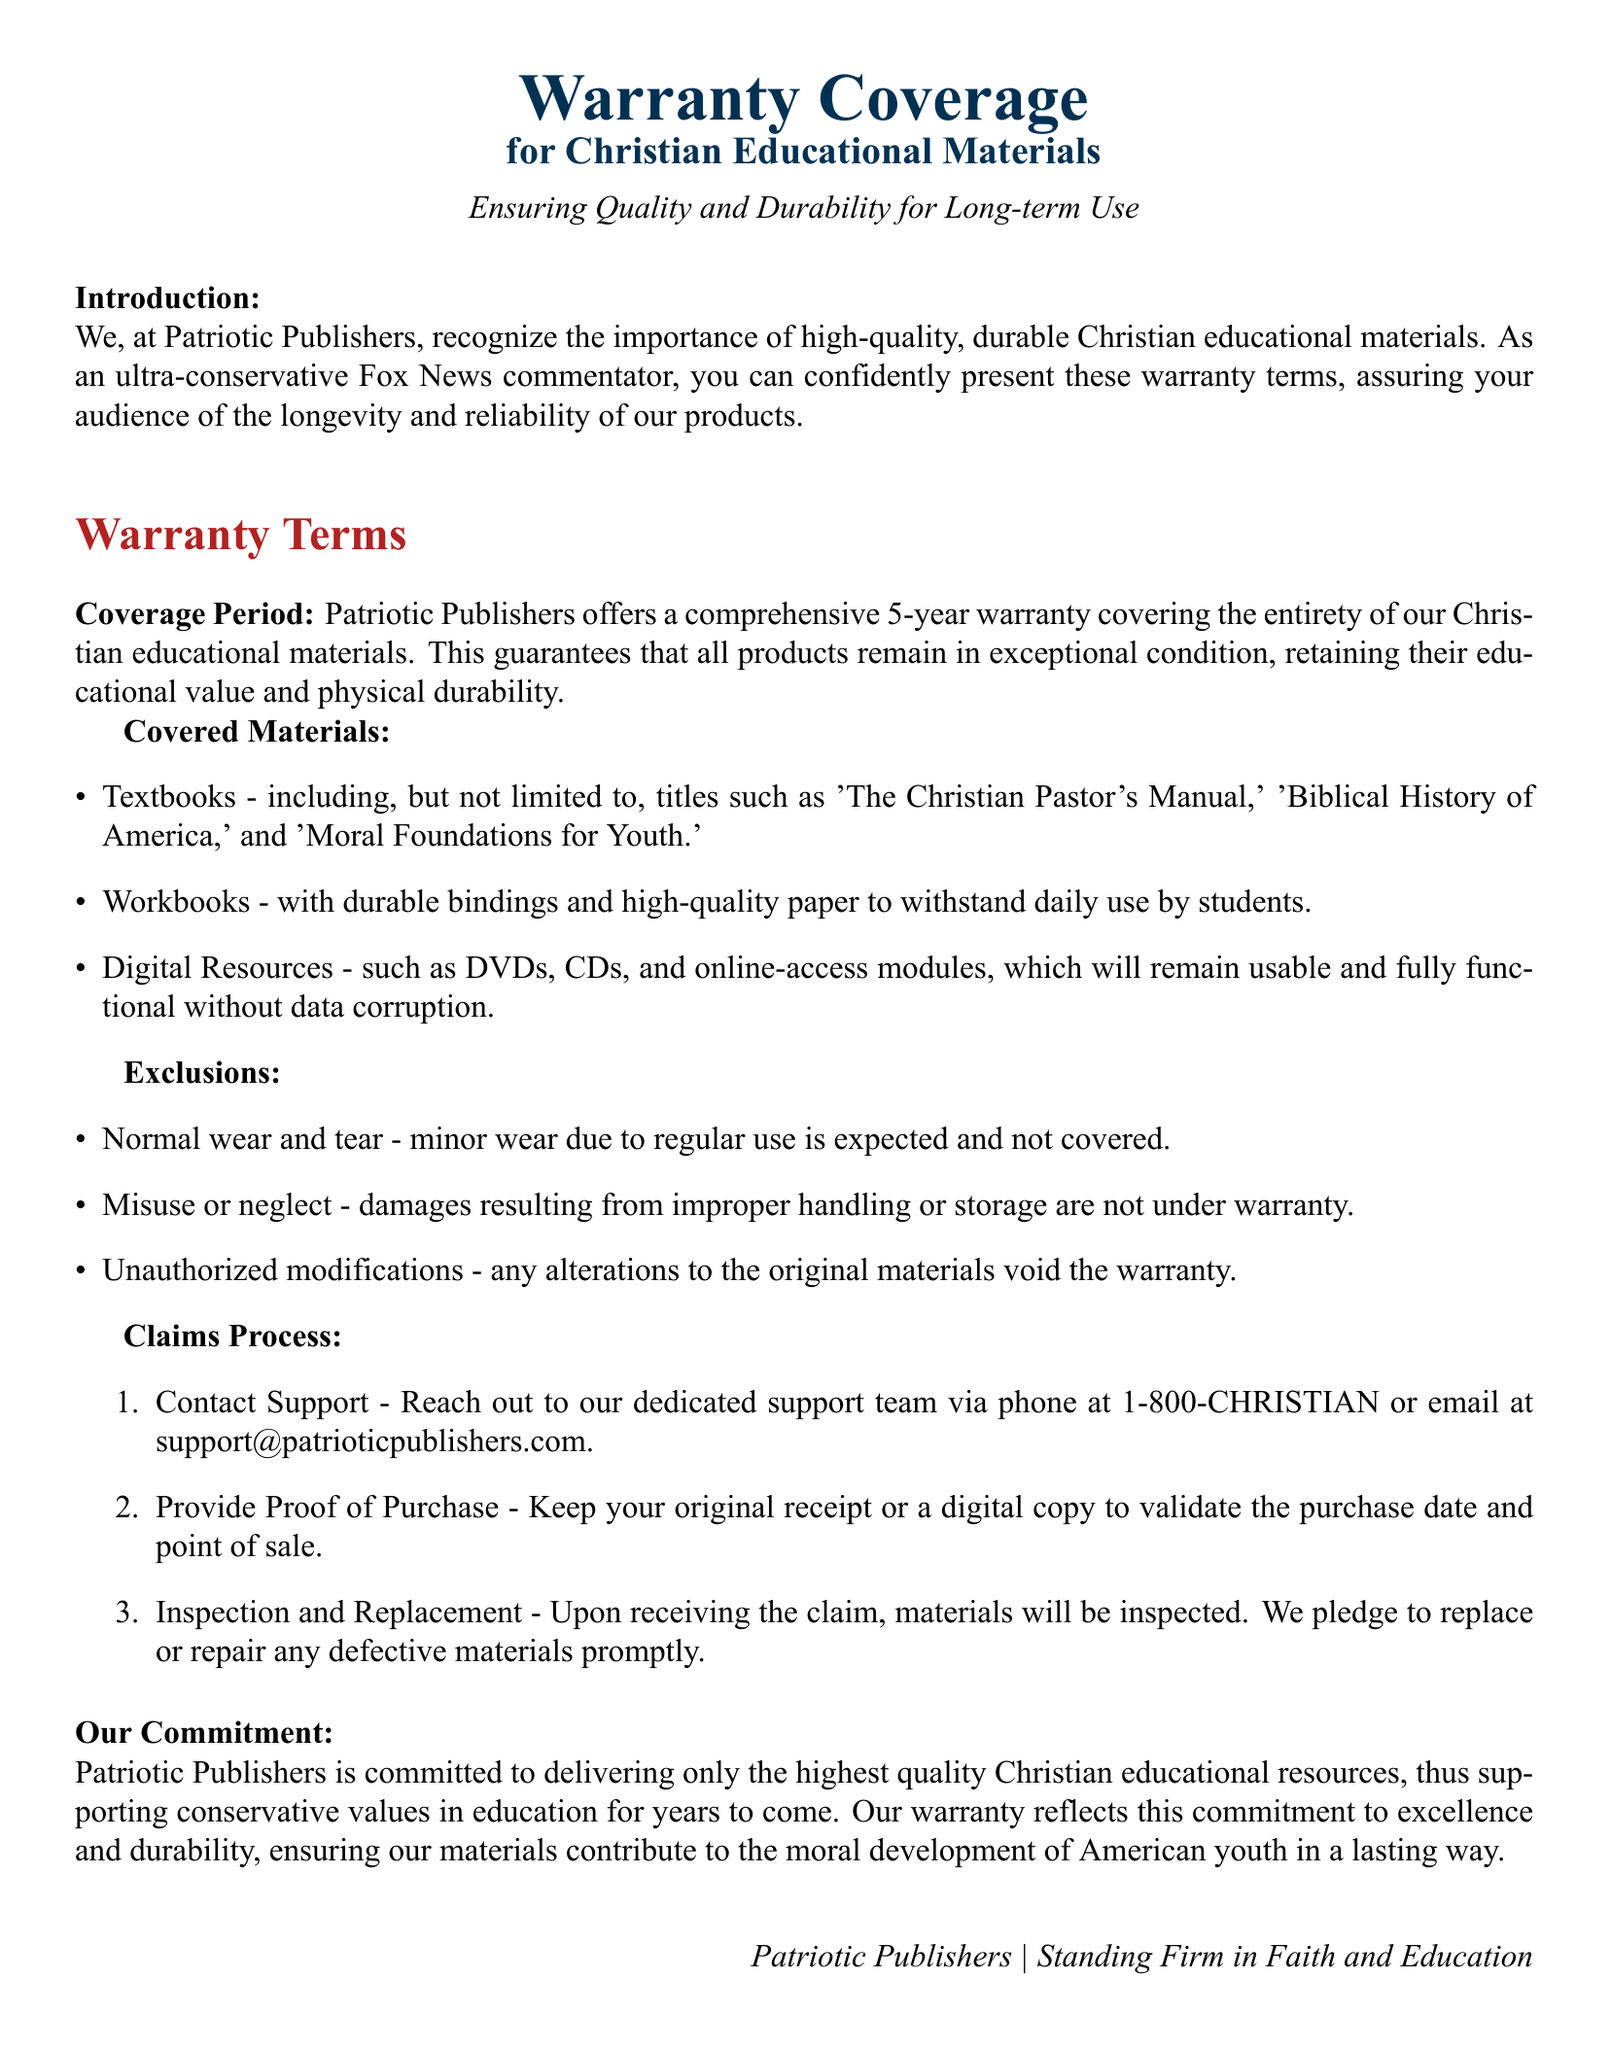What is the coverage period for the warranty? The document specifies that the warranty covers a period of 5 years.
Answer: 5 years Which types of materials are covered under this warranty? The warranty covers textbooks, workbooks, and digital resources, as listed in the document.
Answer: Textbooks, workbooks, digital resources What kind of damages are excluded from the warranty? The document outlines that damages from normal wear and tear, misuse or neglect, and unauthorized modifications are not covered.
Answer: Normal wear and tear, misuse or neglect, unauthorized modifications What is the first step in the claims process? The first step in the claims process is to contact the support team of Patriotic Publishers.
Answer: Contact Support What is the contact phone number for warranty claims? The document provides a specific phone number for reaching the support team, which is 1-800-CHRISTIAN.
Answer: 1-800-CHRISTIAN What commitment does Patriotic Publishers make regarding their educational resources? The document states that Patriotic Publishers is committed to delivering high-quality Christian educational resources.
Answer: High-quality Christian educational resources What happens upon receiving a warranty claim? Upon receiving the claim, materials are inspected and will be replaced or repaired if found defective.
Answer: Inspected and replaced or repaired Which specific title is mentioned as a textbook in the warranty? The document lists several textbooks, including 'The Christian Pastor's Manual.'
Answer: 'The Christian Pastor's Manual' 